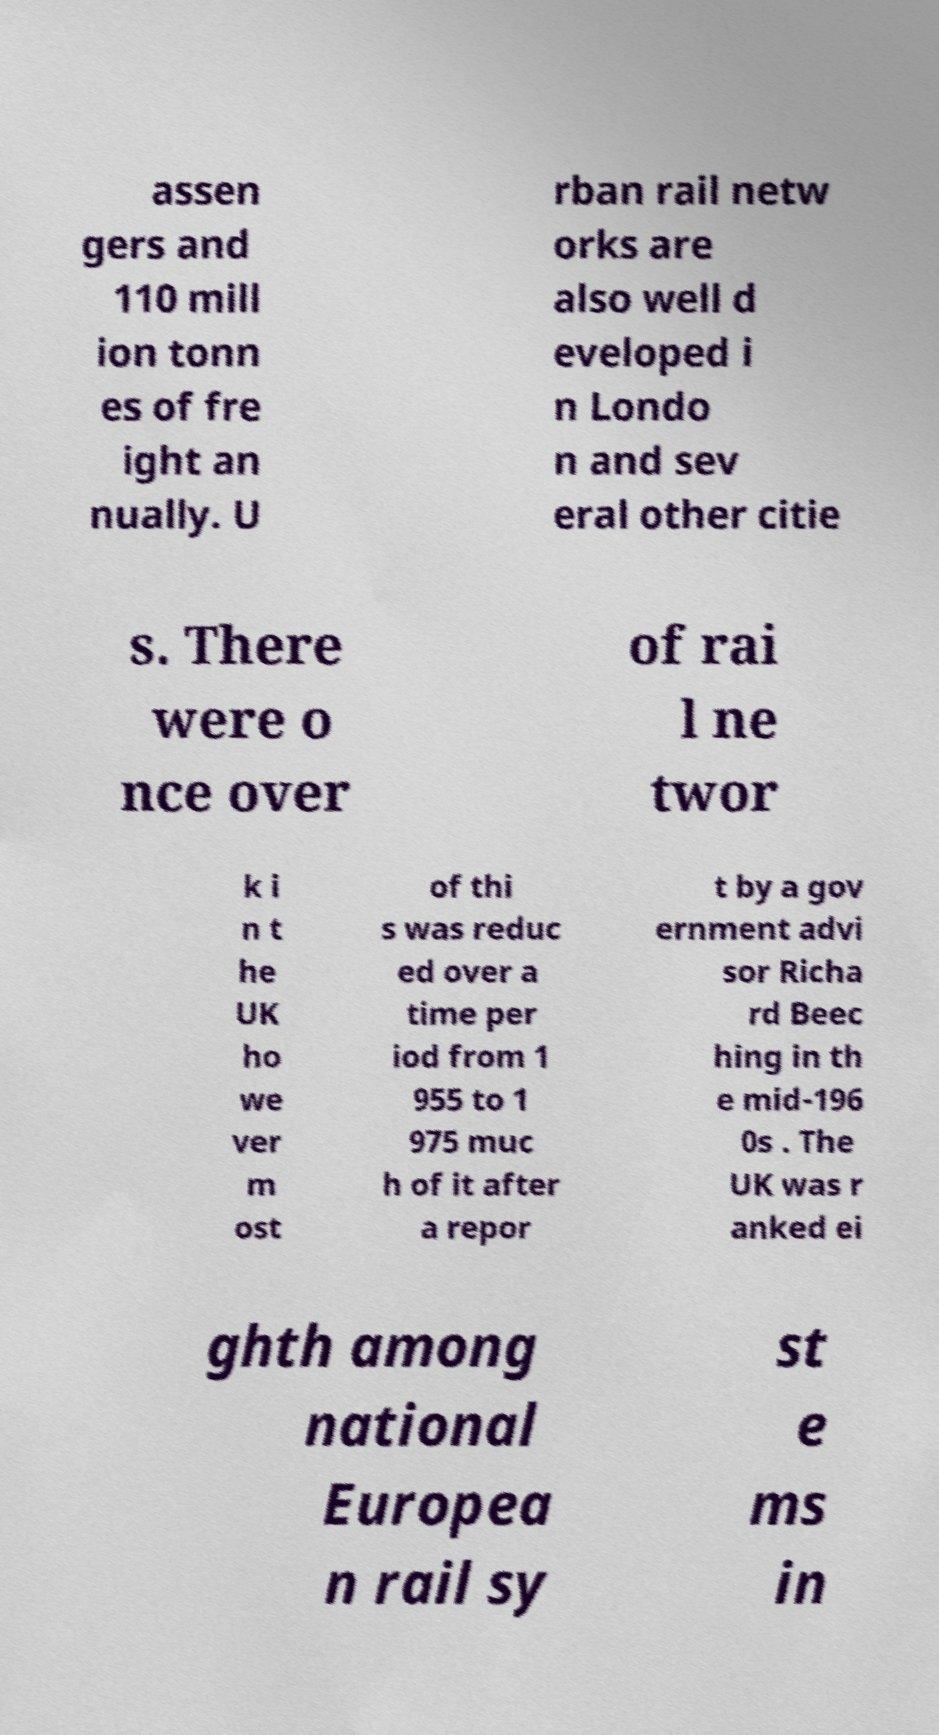Can you accurately transcribe the text from the provided image for me? assen gers and 110 mill ion tonn es of fre ight an nually. U rban rail netw orks are also well d eveloped i n Londo n and sev eral other citie s. There were o nce over of rai l ne twor k i n t he UK ho we ver m ost of thi s was reduc ed over a time per iod from 1 955 to 1 975 muc h of it after a repor t by a gov ernment advi sor Richa rd Beec hing in th e mid-196 0s . The UK was r anked ei ghth among national Europea n rail sy st e ms in 